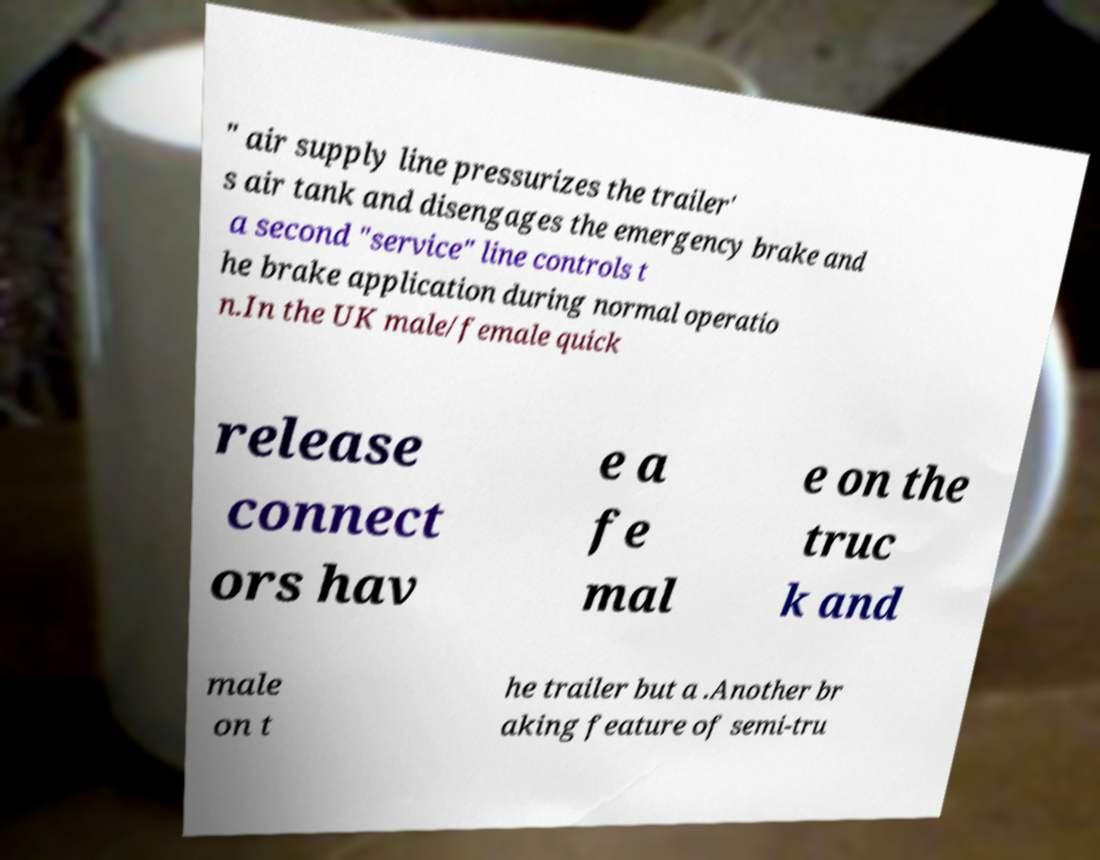Can you read and provide the text displayed in the image?This photo seems to have some interesting text. Can you extract and type it out for me? " air supply line pressurizes the trailer' s air tank and disengages the emergency brake and a second "service" line controls t he brake application during normal operatio n.In the UK male/female quick release connect ors hav e a fe mal e on the truc k and male on t he trailer but a .Another br aking feature of semi-tru 